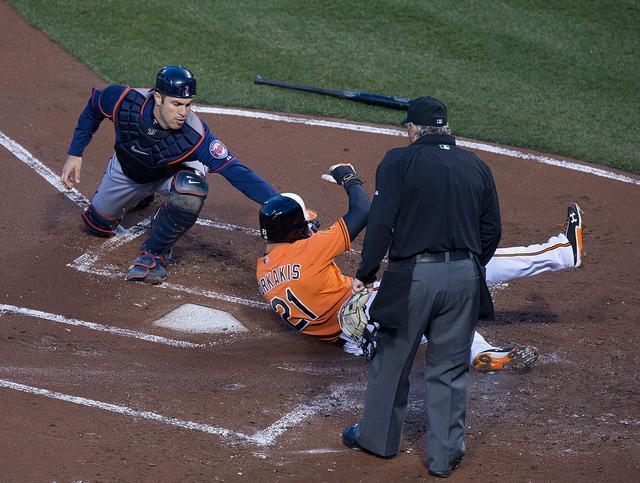How many people are visible?
Give a very brief answer. 3. 